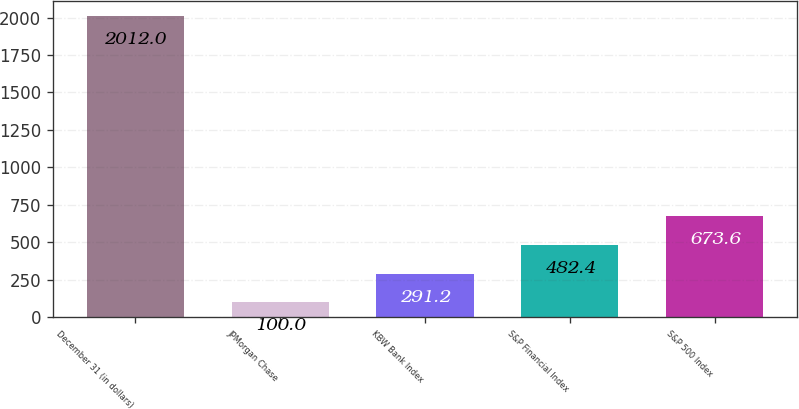Convert chart to OTSL. <chart><loc_0><loc_0><loc_500><loc_500><bar_chart><fcel>December 31 (in dollars)<fcel>JPMorgan Chase<fcel>KBW Bank Index<fcel>S&P Financial Index<fcel>S&P 500 Index<nl><fcel>2012<fcel>100<fcel>291.2<fcel>482.4<fcel>673.6<nl></chart> 